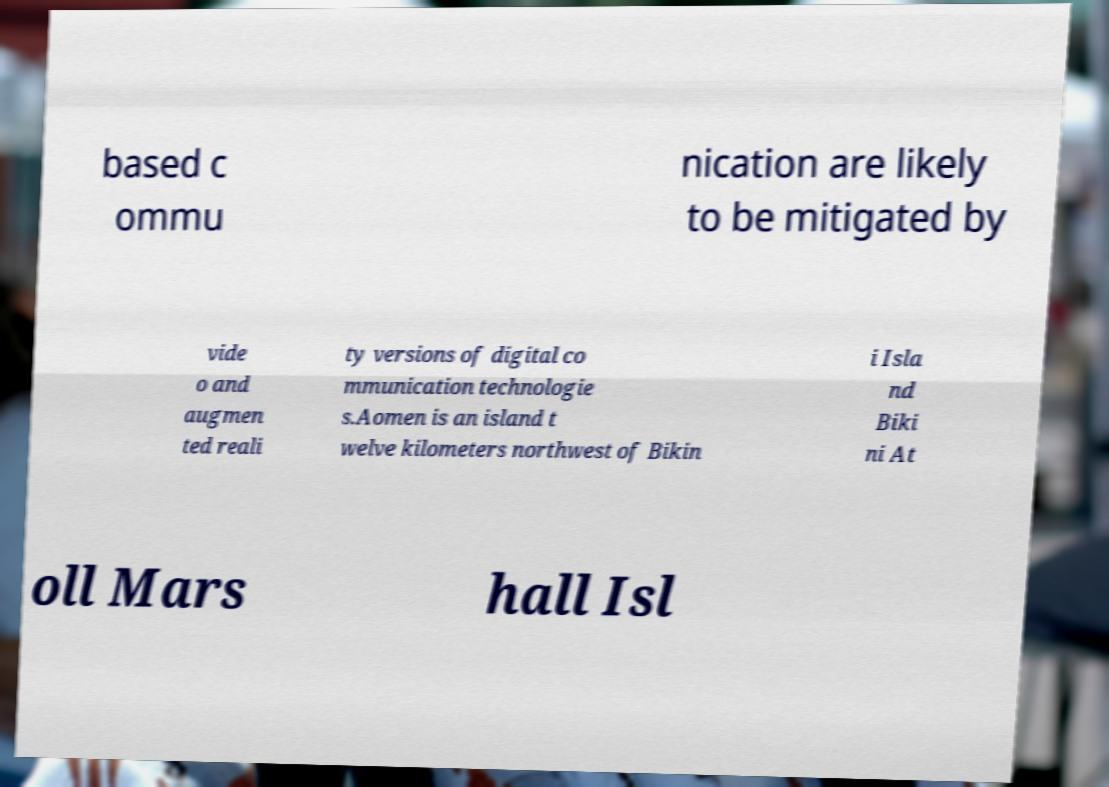Please identify and transcribe the text found in this image. based c ommu nication are likely to be mitigated by vide o and augmen ted reali ty versions of digital co mmunication technologie s.Aomen is an island t welve kilometers northwest of Bikin i Isla nd Biki ni At oll Mars hall Isl 